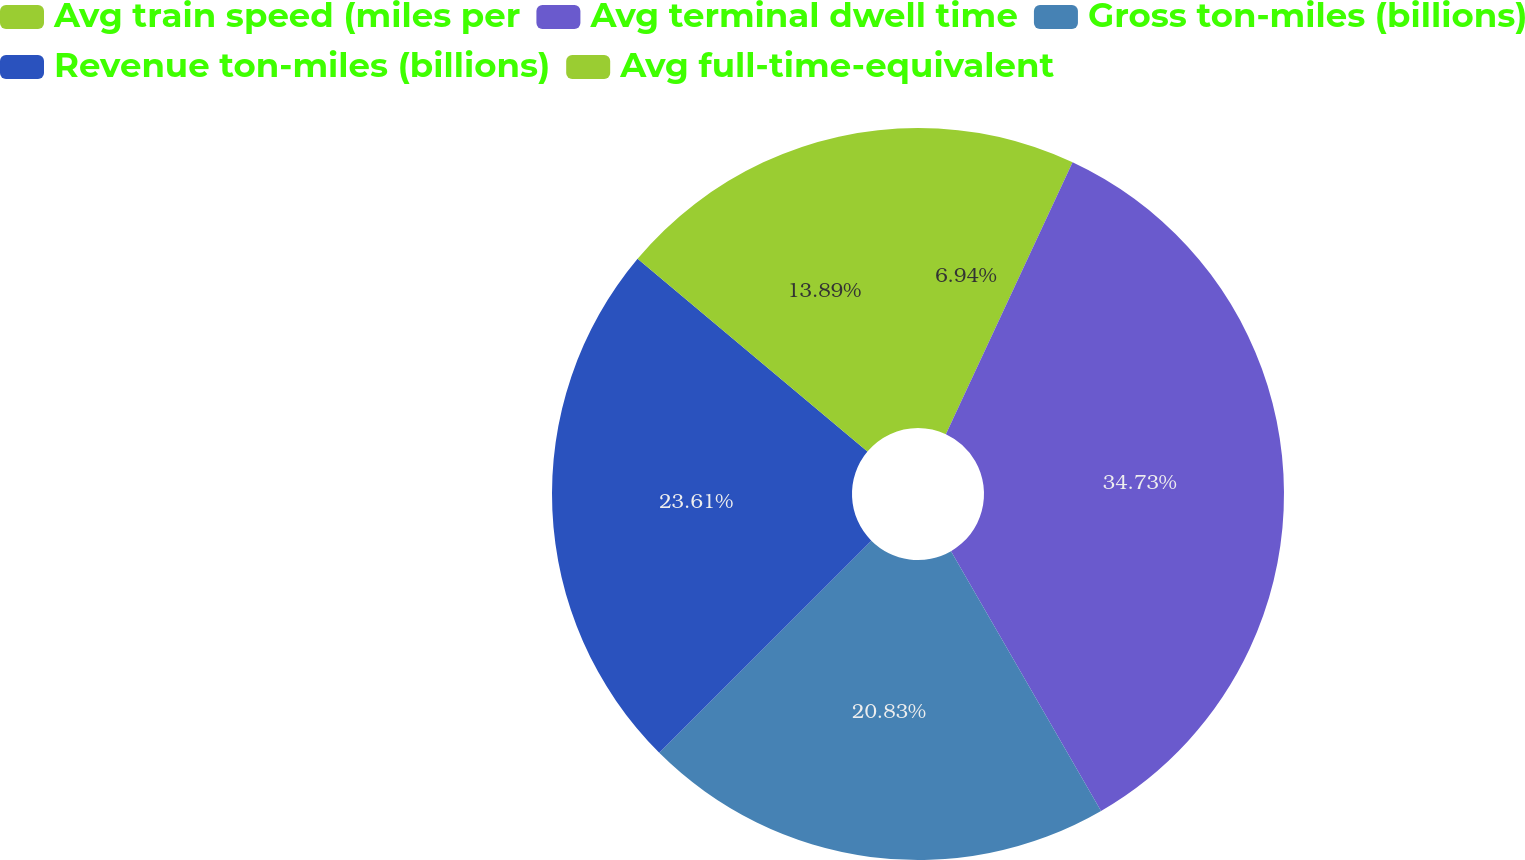<chart> <loc_0><loc_0><loc_500><loc_500><pie_chart><fcel>Avg train speed (miles per<fcel>Avg terminal dwell time<fcel>Gross ton-miles (billions)<fcel>Revenue ton-miles (billions)<fcel>Avg full-time-equivalent<nl><fcel>6.94%<fcel>34.72%<fcel>20.83%<fcel>23.61%<fcel>13.89%<nl></chart> 